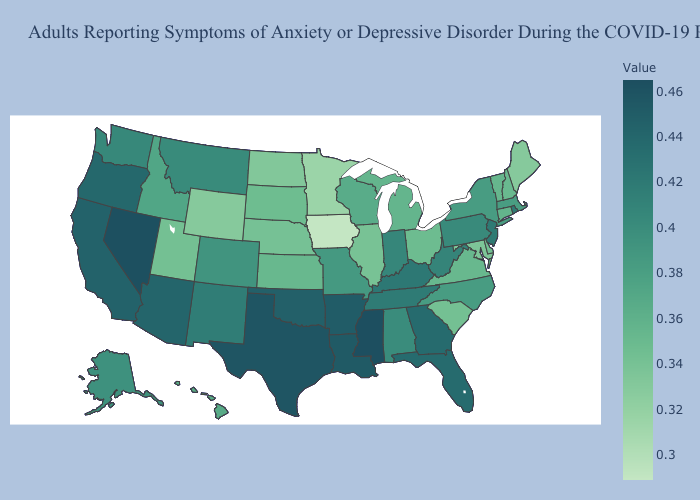Does West Virginia have a lower value than Minnesota?
Short answer required. No. Which states have the lowest value in the USA?
Be succinct. Iowa. Which states have the highest value in the USA?
Give a very brief answer. Mississippi. Does Missouri have a lower value than New Jersey?
Write a very short answer. Yes. Does Ohio have a higher value than Rhode Island?
Concise answer only. No. Which states have the highest value in the USA?
Concise answer only. Mississippi. Which states hav the highest value in the Northeast?
Answer briefly. New Jersey, Rhode Island. 